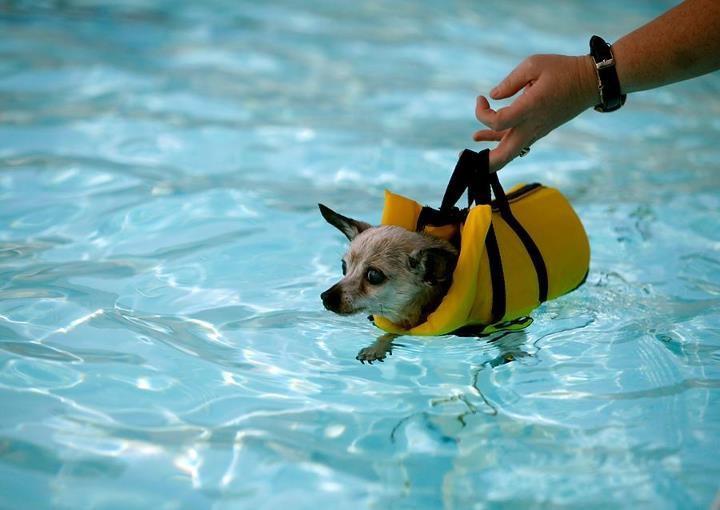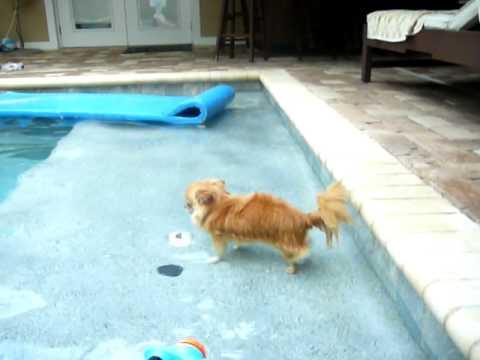The first image is the image on the left, the second image is the image on the right. Considering the images on both sides, is "An image shows a small dog standing on top of a floating raft-type item." valid? Answer yes or no. No. The first image is the image on the left, the second image is the image on the right. Assess this claim about the two images: "A dog is in a swimming pool with a floating device.". Correct or not? Answer yes or no. Yes. 